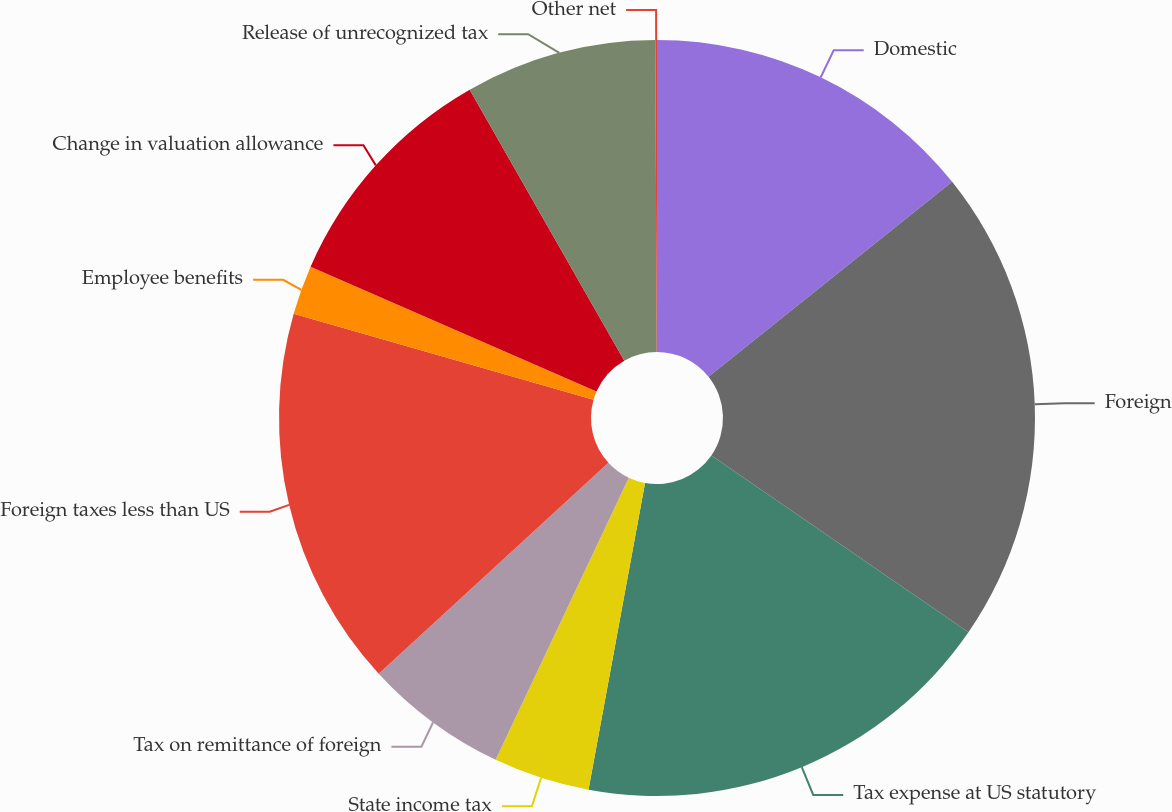Convert chart. <chart><loc_0><loc_0><loc_500><loc_500><pie_chart><fcel>Domestic<fcel>Foreign<fcel>Tax expense at US statutory<fcel>State income tax<fcel>Tax on remittance of foreign<fcel>Foreign taxes less than US<fcel>Employee benefits<fcel>Change in valuation allowance<fcel>Release of unrecognized tax<fcel>Other net<nl><fcel>14.26%<fcel>20.33%<fcel>18.31%<fcel>4.12%<fcel>6.15%<fcel>16.28%<fcel>2.1%<fcel>10.2%<fcel>8.18%<fcel>0.07%<nl></chart> 